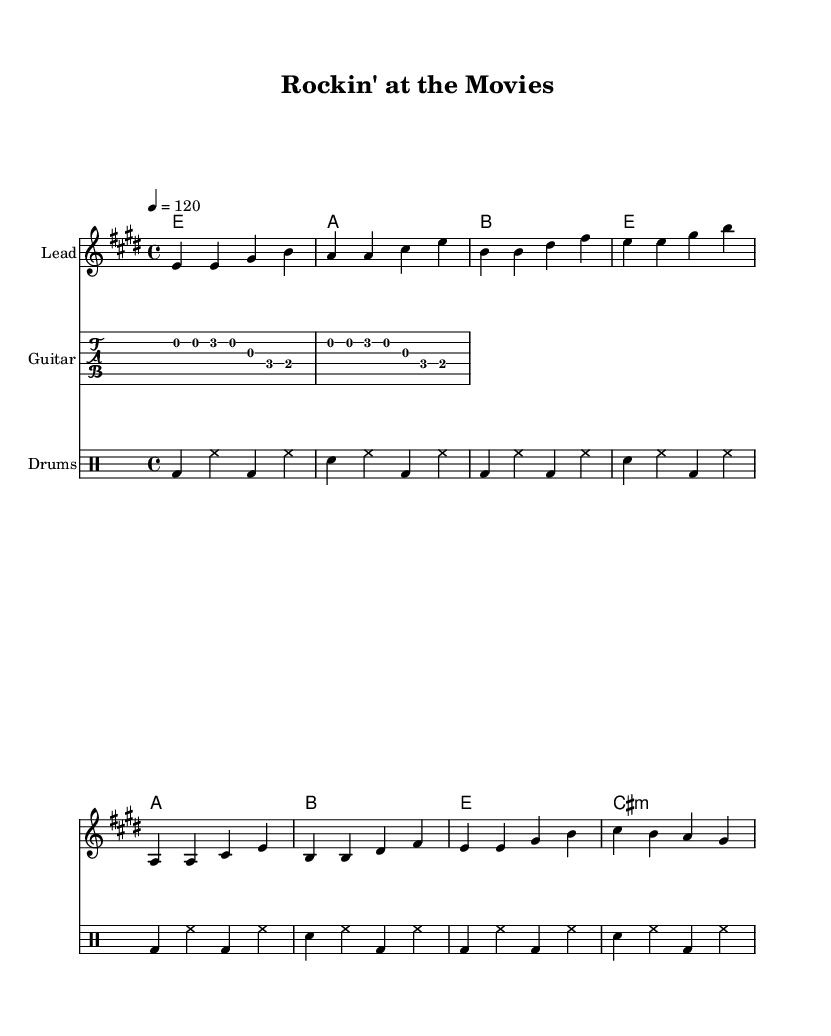What is the key signature of this music? The key signature is indicated at the beginning of the score and shows two sharps, which corresponds to the key of E major.
Answer: E major What is the time signature used in this piece? The time signature is shown at the start of the score and is in the 4/4 format, meaning there are four beats in each measure.
Answer: 4/4 What is the tempo marking for this piece? The tempo is indicated above the staff as a numerical value with a quarter note = 120, suggesting a moderately fast pace.
Answer: 120 How many measures are in the verse section? By counting the groups of notes in the verse notation, there are four measures shown in that section.
Answer: 4 What is the structure of the song? The song consists of a verse followed by a chorus, as inferred from the section labels and the organization of the notes and lyrics.
Answer: Verse-Chorus How many instruments are represented in the score? The score displays three separate staves representing different instruments: lead, guitar, and drums, making a total of three instruments.
Answer: 3 What type of musical style does this score represent? The characteristic elements, such as strong rhythms and electric guitar riffs, indicate that it belongs to the rock genre.
Answer: Rock 